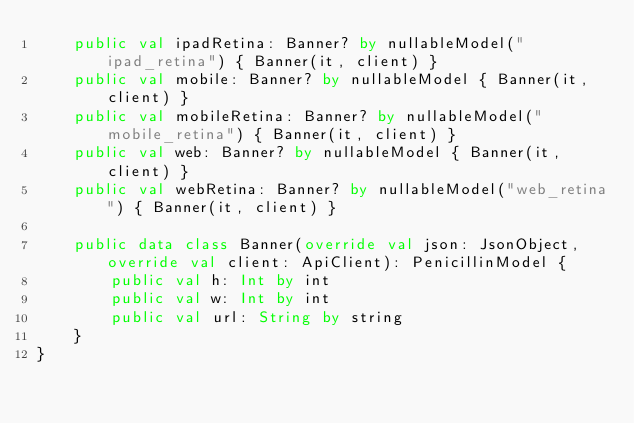Convert code to text. <code><loc_0><loc_0><loc_500><loc_500><_Kotlin_>    public val ipadRetina: Banner? by nullableModel("ipad_retina") { Banner(it, client) }
    public val mobile: Banner? by nullableModel { Banner(it, client) }
    public val mobileRetina: Banner? by nullableModel("mobile_retina") { Banner(it, client) }
    public val web: Banner? by nullableModel { Banner(it, client) }
    public val webRetina: Banner? by nullableModel("web_retina") { Banner(it, client) }

    public data class Banner(override val json: JsonObject, override val client: ApiClient): PenicillinModel {
        public val h: Int by int
        public val w: Int by int
        public val url: String by string
    }
}
</code> 